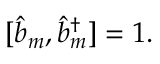<formula> <loc_0><loc_0><loc_500><loc_500>[ \hat { b } _ { m } , \hat { b } _ { m } ^ { \dagger } ] = 1 .</formula> 